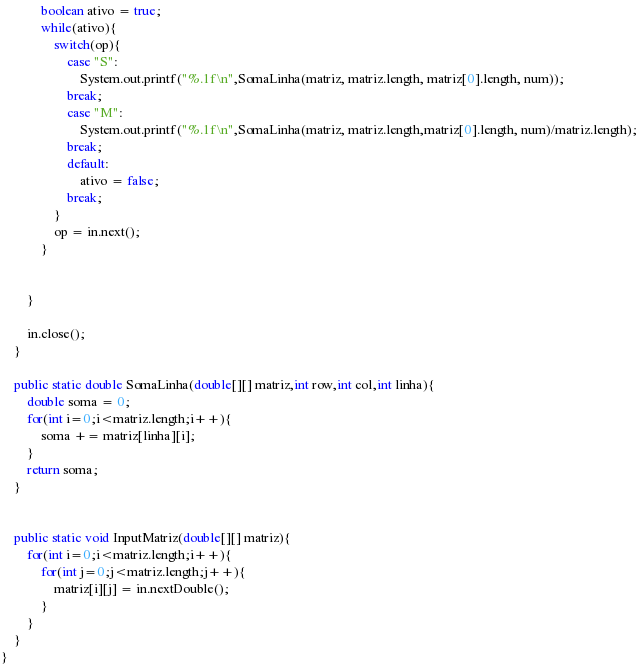<code> <loc_0><loc_0><loc_500><loc_500><_Java_>            boolean ativo = true;
            while(ativo){
                switch(op){
                    case "S":
                        System.out.printf("%.1f\n",SomaLinha(matriz, matriz.length, matriz[0].length, num));
                    break;
                    case "M":
                        System.out.printf("%.1f\n",SomaLinha(matriz, matriz.length,matriz[0].length, num)/matriz.length);
                    break;
                    default:
                        ativo = false;
                    break;
                }
                op = in.next();
            }
            

        }

        in.close();
    }

    public static double SomaLinha(double[][] matriz,int row,int col,int linha){
        double soma = 0;
        for(int i=0;i<matriz.length;i++){
            soma += matriz[linha][i];
        }
        return soma;
    }


    public static void InputMatriz(double[][] matriz){
        for(int i=0;i<matriz.length;i++){
            for(int j=0;j<matriz.length;j++){
                matriz[i][j] = in.nextDouble();
            }
        }
    }
}</code> 